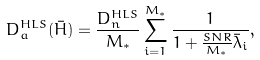<formula> <loc_0><loc_0><loc_500><loc_500>D _ { a } ^ { H L S } ( \bar { H } ) = \frac { D _ { n } ^ { H L S } } { M _ { * } } \sum _ { i = 1 } ^ { M _ { * } } \frac { 1 } { 1 + \frac { S N R } { M _ { * } } \bar { \lambda } _ { i } } ,</formula> 